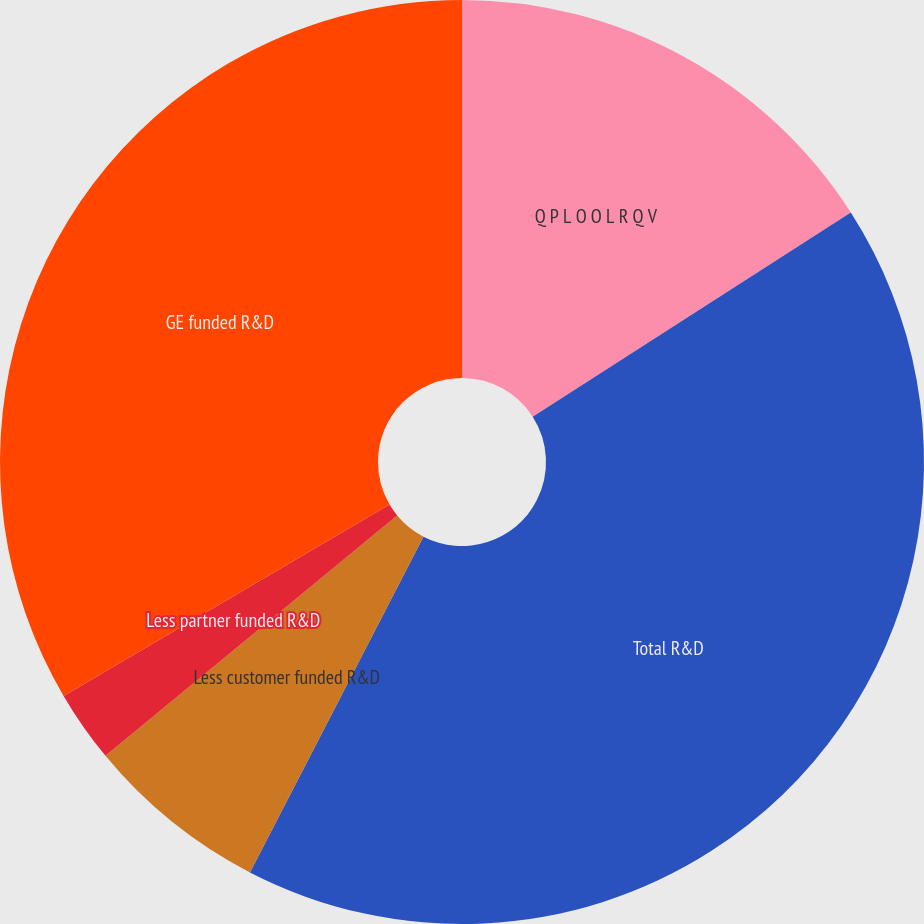Convert chart to OTSL. <chart><loc_0><loc_0><loc_500><loc_500><pie_chart><fcel>Q P L O O L R Q V<fcel>Total R&D<fcel>Less customer funded R&D<fcel>Less partner funded R&D<fcel>GE funded R&D<nl><fcel>15.92%<fcel>41.67%<fcel>6.44%<fcel>2.52%<fcel>33.45%<nl></chart> 